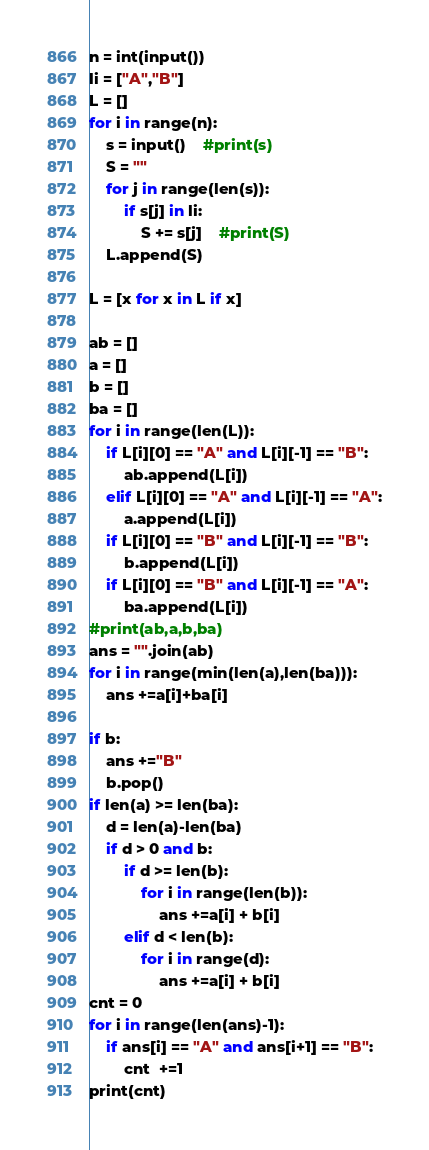<code> <loc_0><loc_0><loc_500><loc_500><_Python_>n = int(input())
li = ["A","B"]
L = []
for i in range(n):
    s = input()    #print(s)
    S = ""
    for j in range(len(s)):
        if s[j] in li:
            S += s[j]    #print(S)
    L.append(S)

L = [x for x in L if x]

ab = []
a = []
b = []
ba = []
for i in range(len(L)):
    if L[i][0] == "A" and L[i][-1] == "B":
        ab.append(L[i])
    elif L[i][0] == "A" and L[i][-1] == "A":
        a.append(L[i])
    if L[i][0] == "B" and L[i][-1] == "B":
        b.append(L[i])
    if L[i][0] == "B" and L[i][-1] == "A":
        ba.append(L[i])
#print(ab,a,b,ba)
ans = "".join(ab)
for i in range(min(len(a),len(ba))):
    ans +=a[i]+ba[i]

if b:
    ans +="B"
    b.pop()
if len(a) >= len(ba):
    d = len(a)-len(ba)
    if d > 0 and b:
        if d >= len(b):
            for i in range(len(b)):
                ans +=a[i] + b[i]
        elif d < len(b):
            for i in range(d):
                ans +=a[i] + b[i]
cnt = 0
for i in range(len(ans)-1):
    if ans[i] == "A" and ans[i+1] == "B":
        cnt  +=1
print(cnt)</code> 